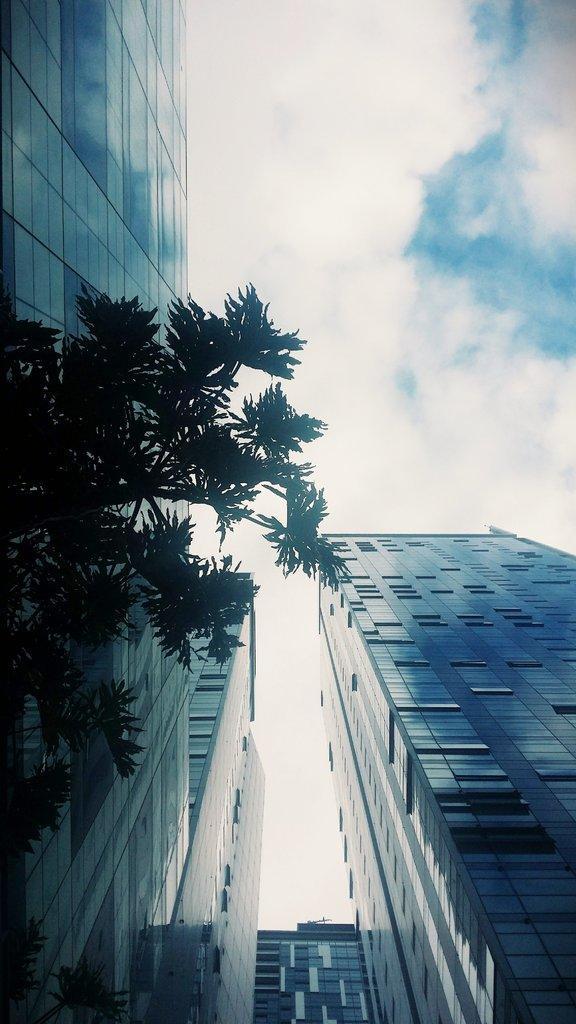Please provide a concise description of this image. In this image, we can see some buildings and there is a green color tree, we can see a sky which is cloudy. 